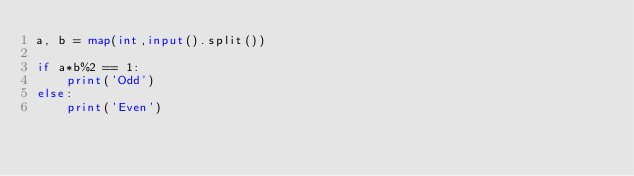<code> <loc_0><loc_0><loc_500><loc_500><_Python_>a, b = map(int,input().split())

if a*b%2 == 1:
    print('Odd')
else:
    print('Even')</code> 